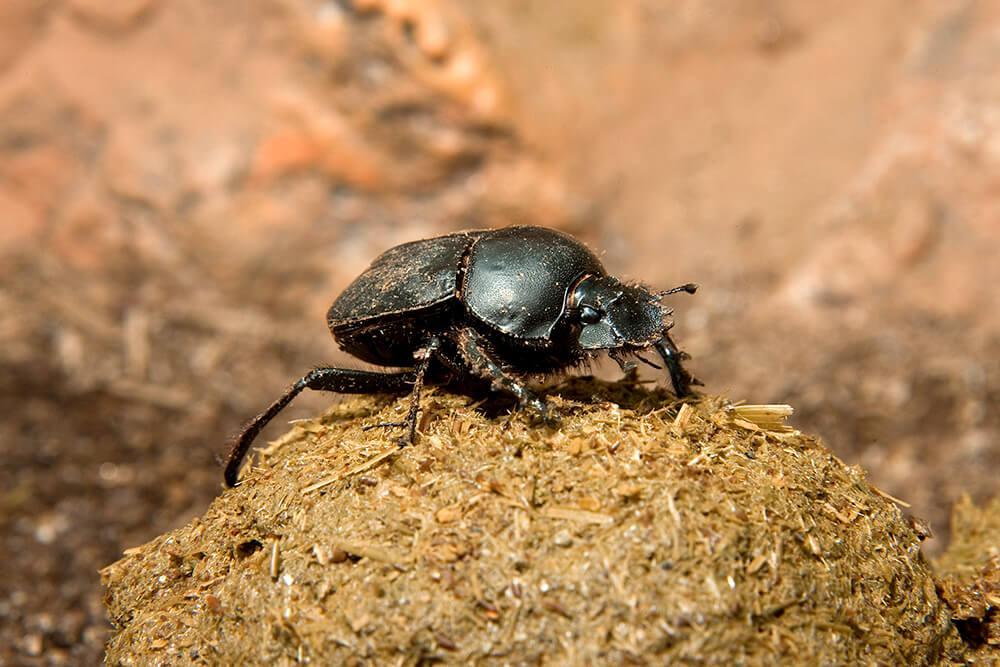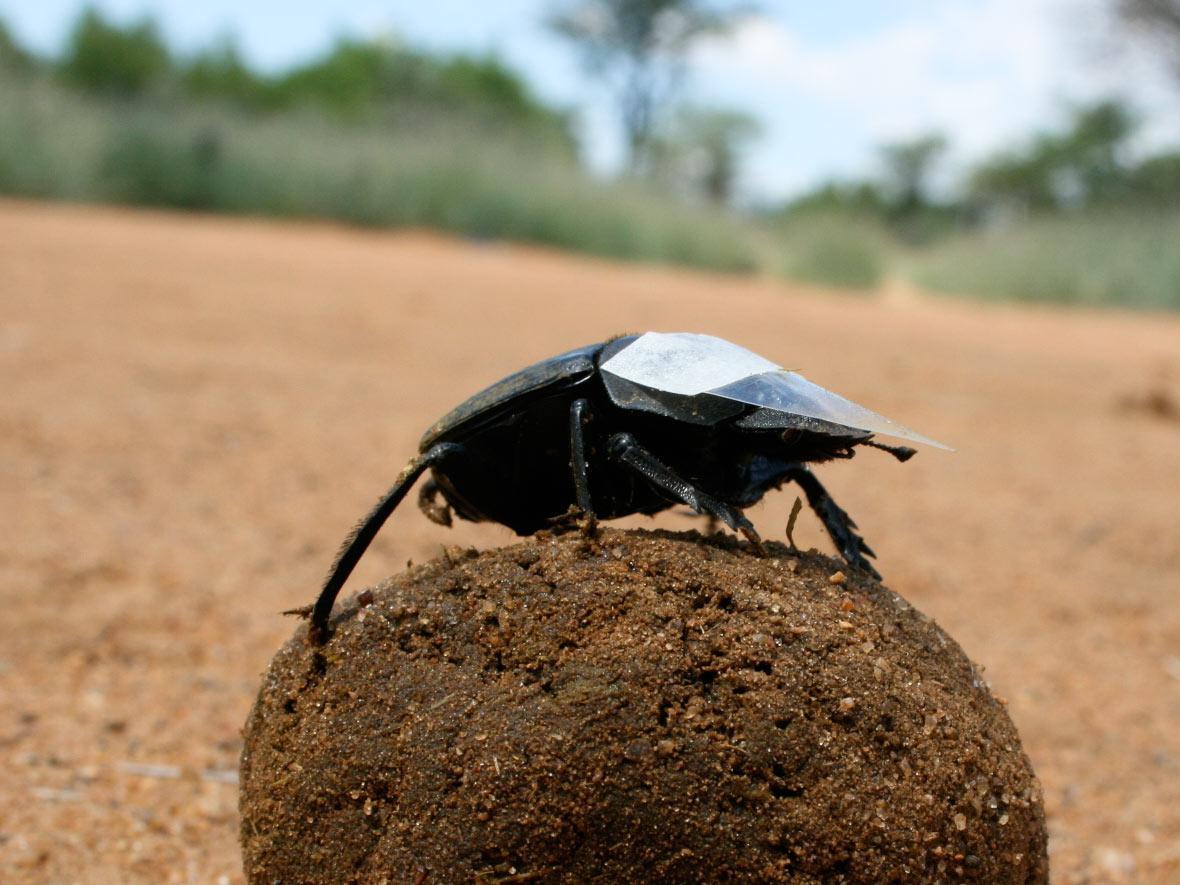The first image is the image on the left, the second image is the image on the right. For the images displayed, is the sentence "Each image shows exactly one beetle." factually correct? Answer yes or no. Yes. The first image is the image on the left, the second image is the image on the right. For the images shown, is this caption "An image in the pair shows exactly two beetles with a dung ball." true? Answer yes or no. No. 